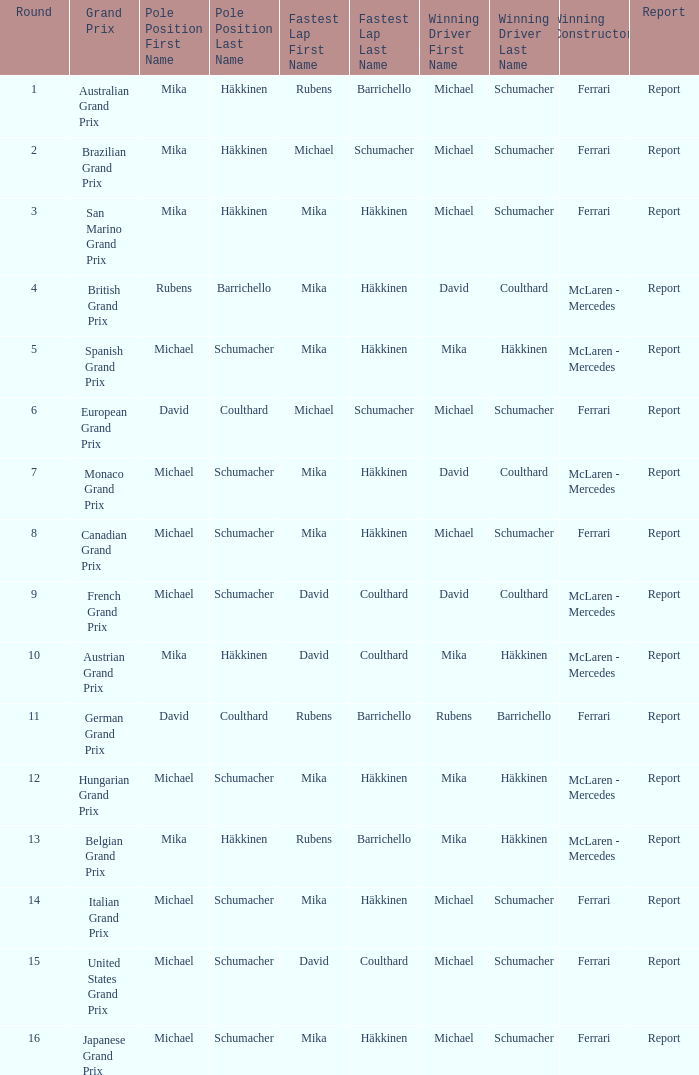What was the report of the Belgian Grand Prix? Report. 